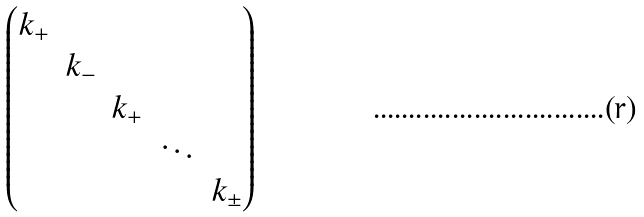Convert formula to latex. <formula><loc_0><loc_0><loc_500><loc_500>\begin{pmatrix} k _ { + } & \\ & k _ { - } \\ & & k _ { + } & \\ & & & \ddots \\ & & & & k _ { \pm } \end{pmatrix}</formula> 